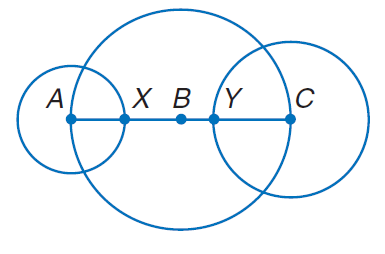Question: The diameters of \odot A, \odot B, and \odot C are 10 inches, 20 inches, and 14 inches, respectively. Find B Y.
Choices:
A. 3
B. 6
C. 9
D. 12
Answer with the letter. Answer: A 